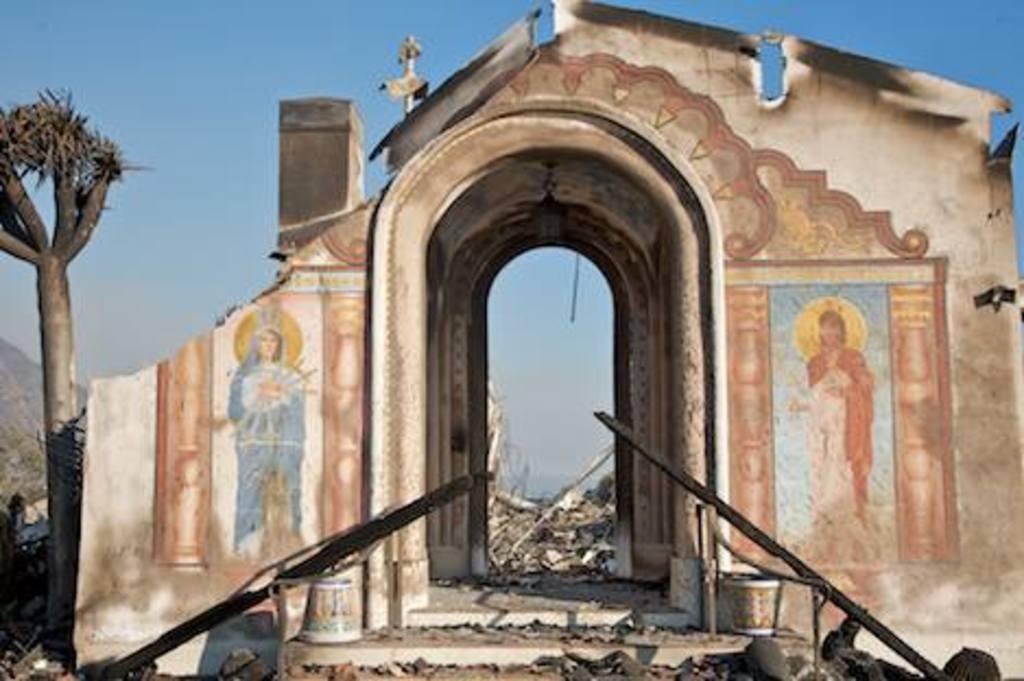Can you describe this image briefly? This picture is clicked outside. In the foreground we can see the objects placed on the ground. In the center we can see an object seems to be the house and we can see the pictures of some persons on the wall of the house. On the left corner we can see the tree. In the background there is a sky and we can see the hills and many other objects. 